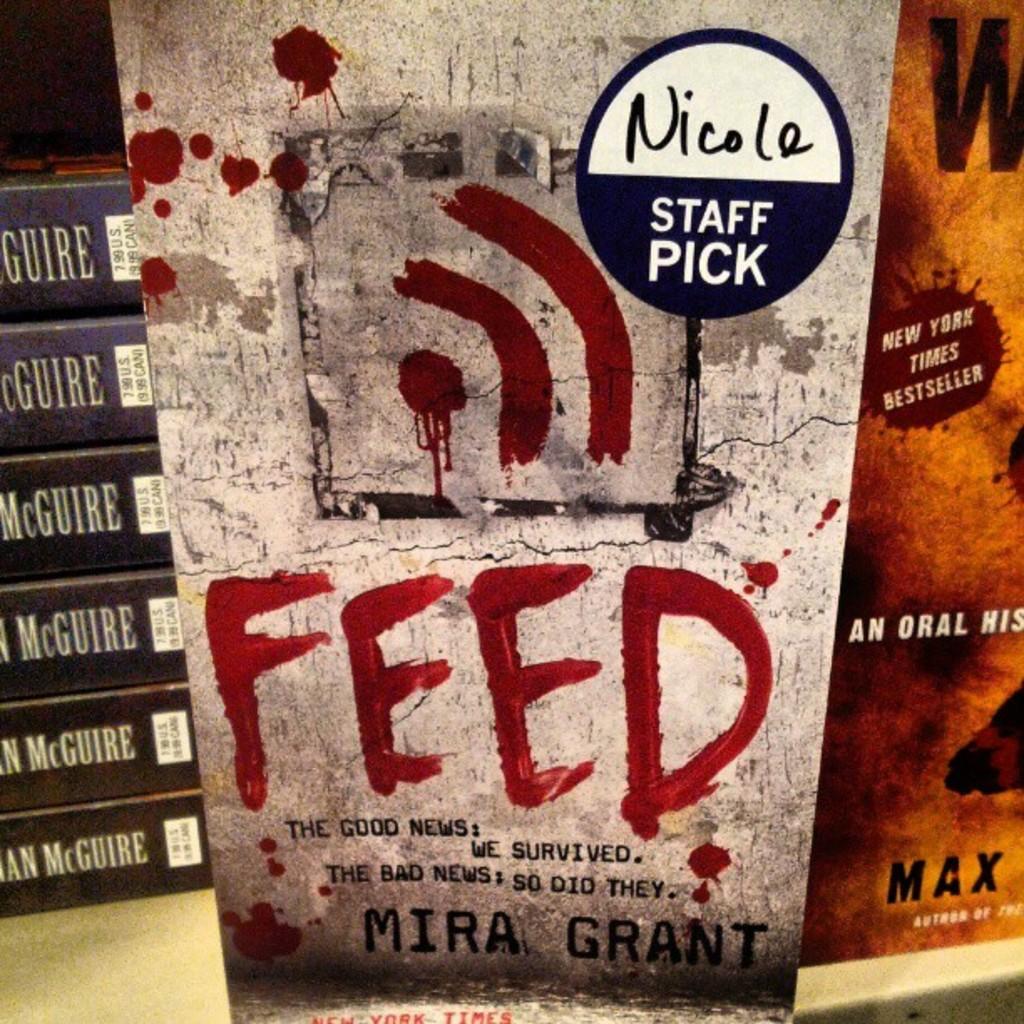Is mira grant a good author?
Provide a succinct answer. Unanswerable. 